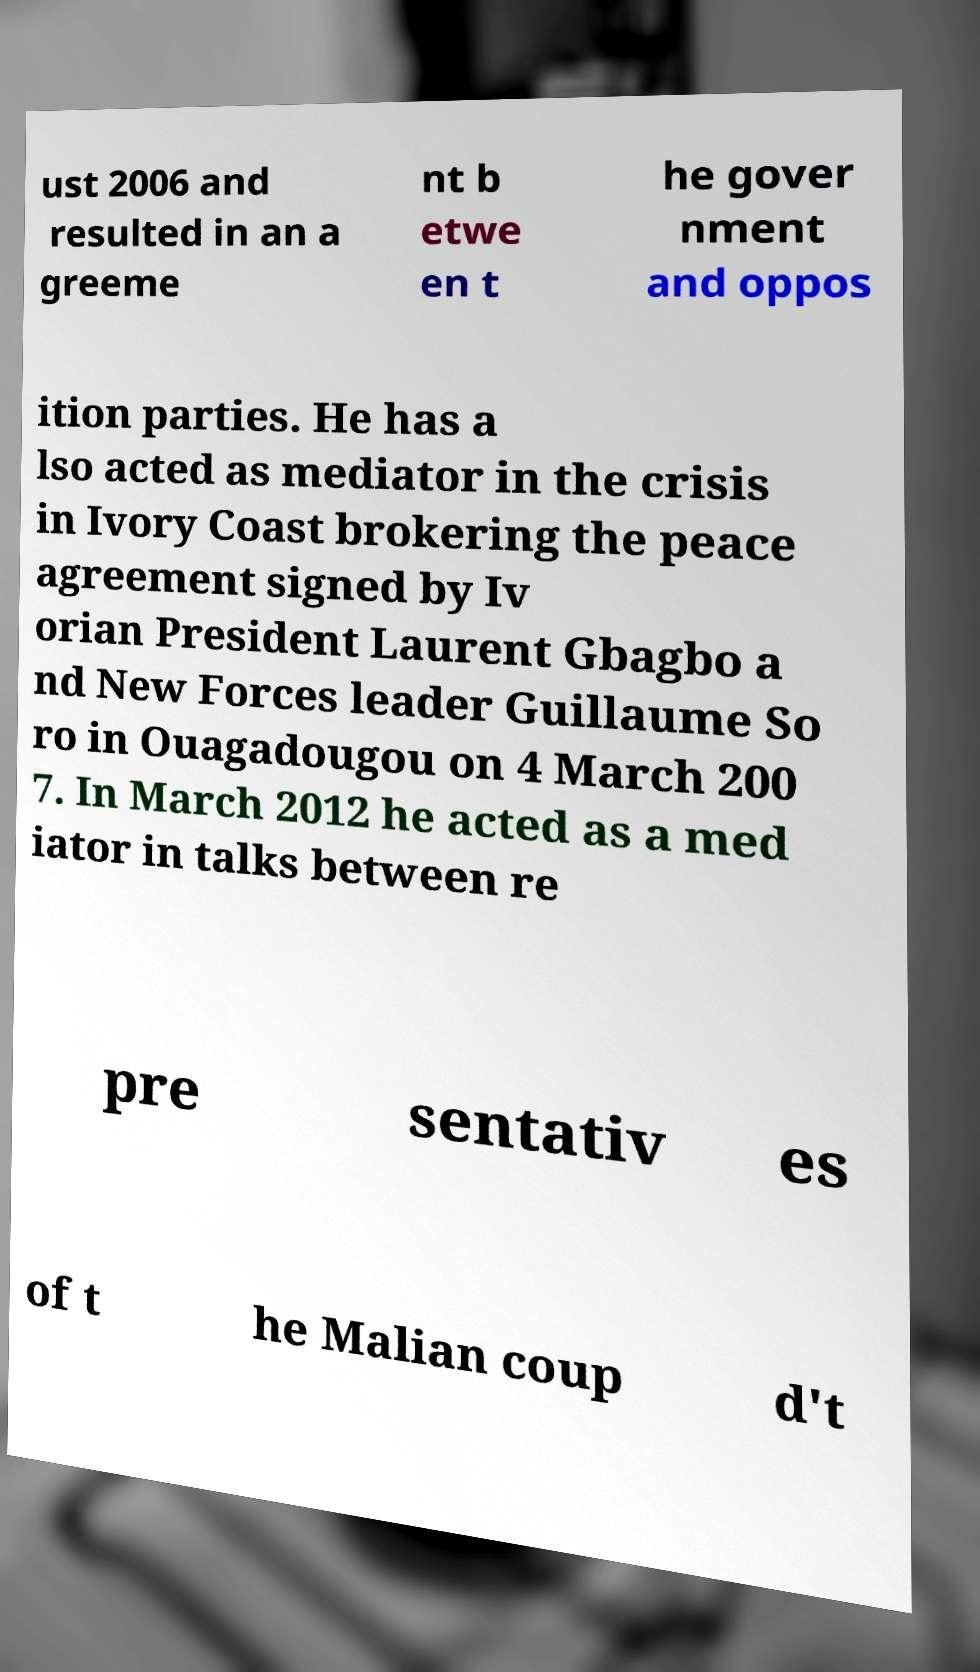Could you assist in decoding the text presented in this image and type it out clearly? ust 2006 and resulted in an a greeme nt b etwe en t he gover nment and oppos ition parties. He has a lso acted as mediator in the crisis in Ivory Coast brokering the peace agreement signed by Iv orian President Laurent Gbagbo a nd New Forces leader Guillaume So ro in Ouagadougou on 4 March 200 7. In March 2012 he acted as a med iator in talks between re pre sentativ es of t he Malian coup d't 